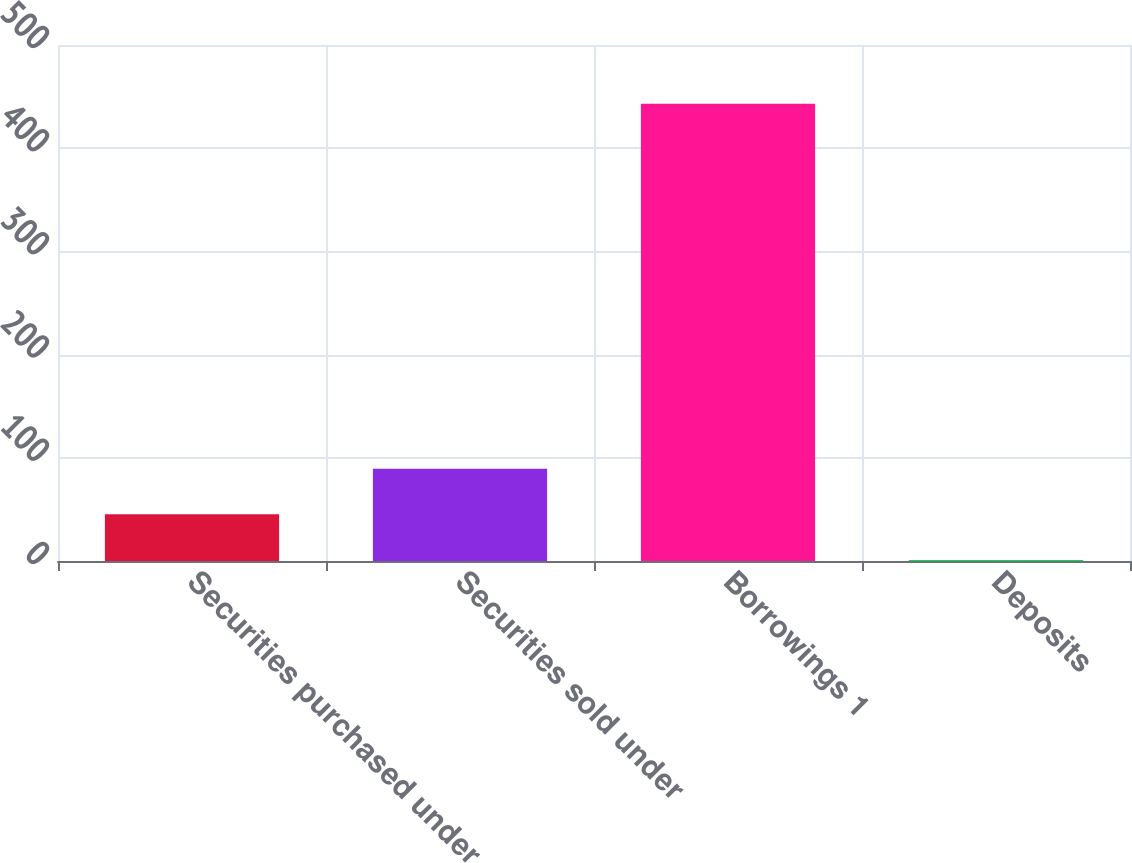Convert chart to OTSL. <chart><loc_0><loc_0><loc_500><loc_500><bar_chart><fcel>Securities purchased under<fcel>Securities sold under<fcel>Borrowings 1<fcel>Deposits<nl><fcel>45.2<fcel>89.4<fcel>443<fcel>1<nl></chart> 